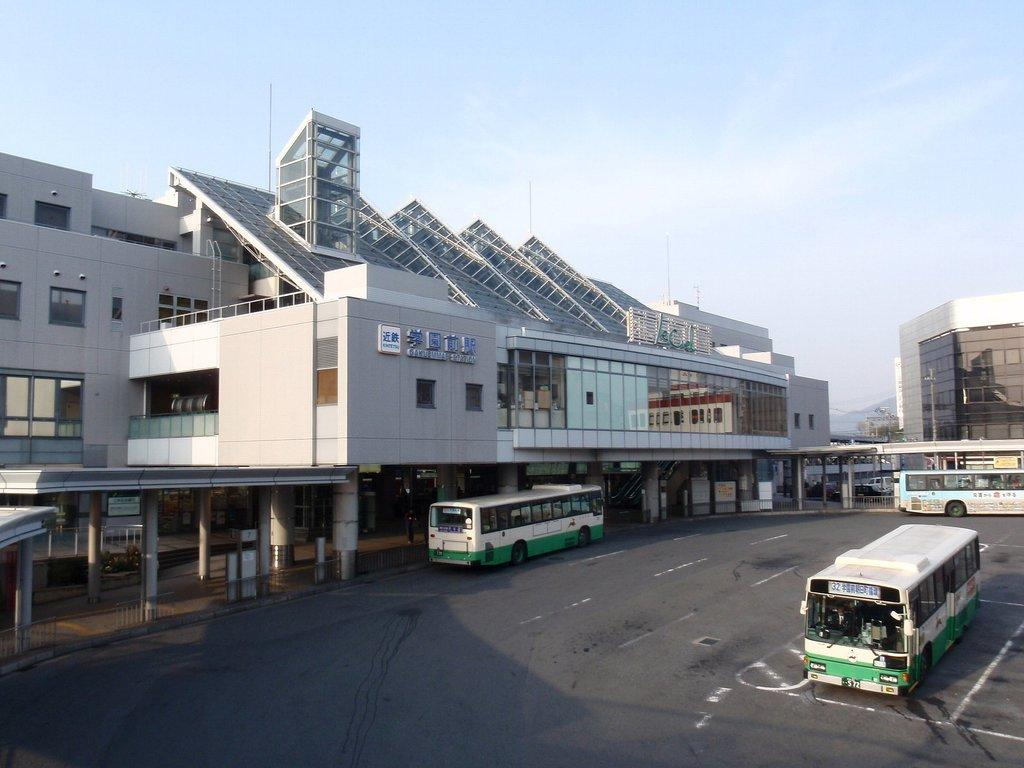What can be seen in the image? There are vehicles in the image. What else can be seen in the background of the image? There are buildings in the background of the image. How would you describe the sky in the image? The sky is visible in the image, with a combination of white and blue colors. Where is the baby in the image? There is no baby present in the image. What type of spot can be seen on the vehicles in the image? There is no mention of spots on the vehicles in the image. 